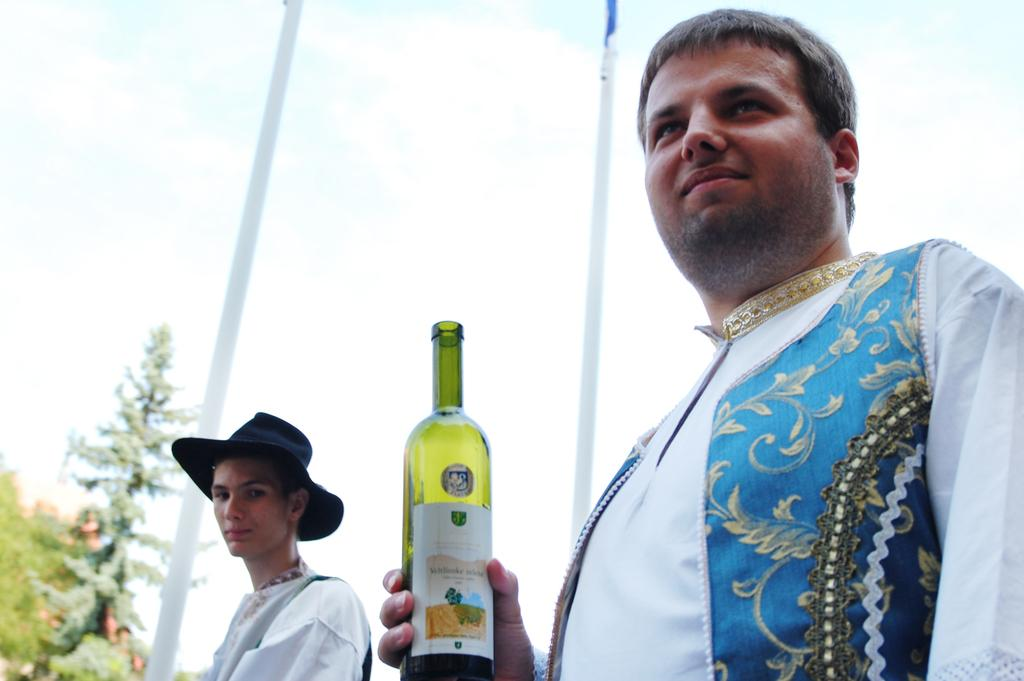Who is present in the image? There is a guy and another boy in the image. What is the guy wearing? The guy is wearing a white and blue dress. What is the guy holding? The guy is holding a bottle. What is the other boy wearing? The other boy is wearing a hat. How many goldfish are swimming in the hat of the other boy? There are no goldfish present in the image, and the hat of the other boy does not contain any goldfish. 